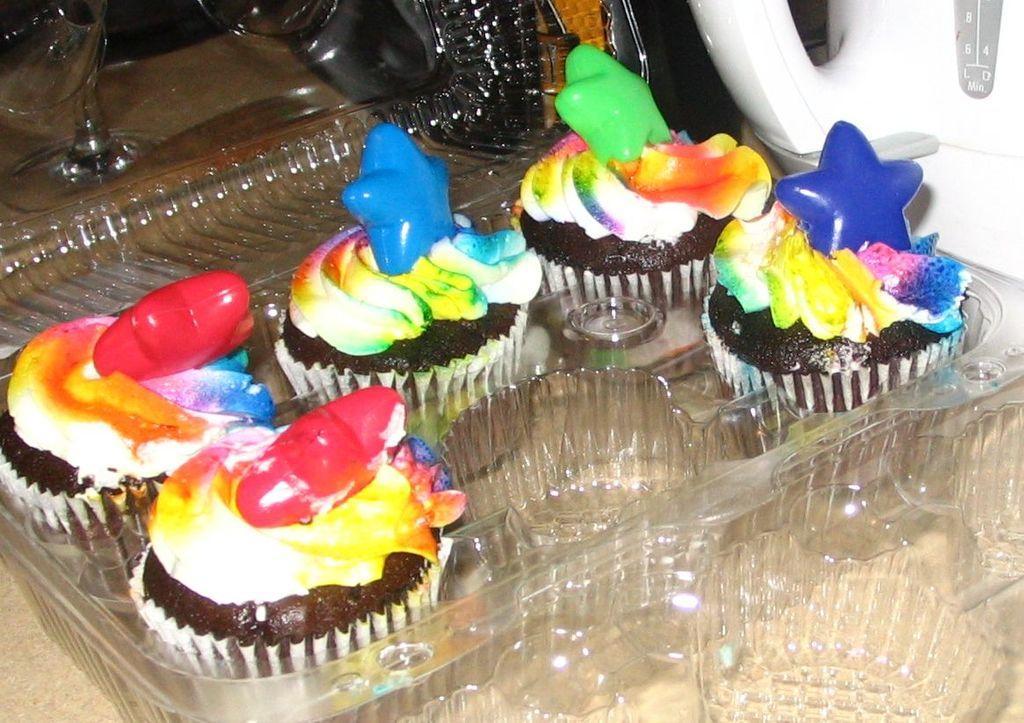Can you describe this image briefly? In this image there is food in the plastic box which is on the table in the center. On the right side there is a jar which is white in colour. On the left side there are glasses. 